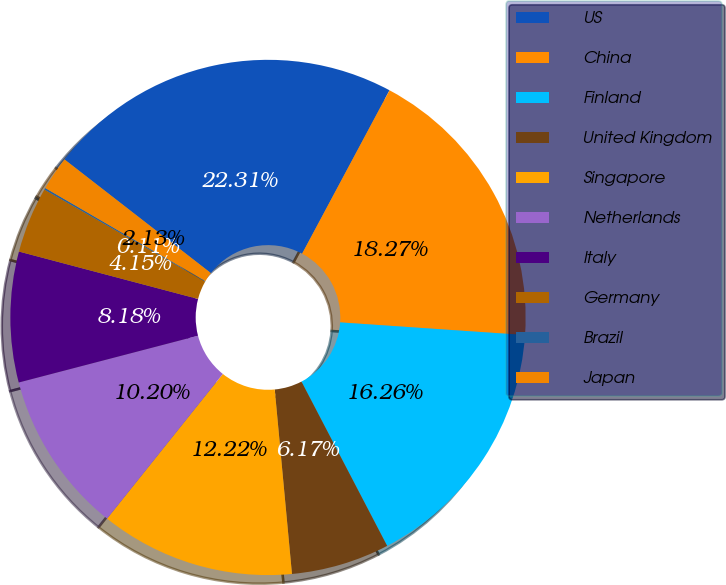Convert chart to OTSL. <chart><loc_0><loc_0><loc_500><loc_500><pie_chart><fcel>US<fcel>China<fcel>Finland<fcel>United Kingdom<fcel>Singapore<fcel>Netherlands<fcel>Italy<fcel>Germany<fcel>Brazil<fcel>Japan<nl><fcel>22.31%<fcel>18.27%<fcel>16.26%<fcel>6.17%<fcel>12.22%<fcel>10.2%<fcel>8.18%<fcel>4.15%<fcel>0.11%<fcel>2.13%<nl></chart> 